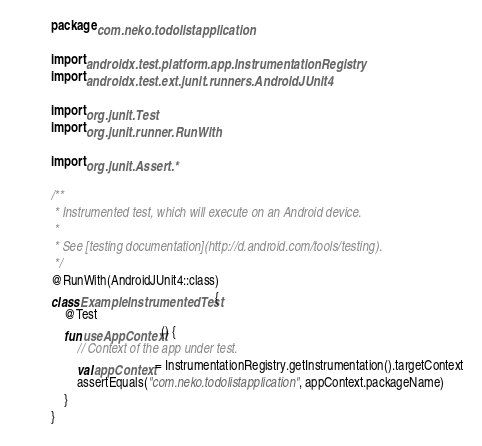Convert code to text. <code><loc_0><loc_0><loc_500><loc_500><_Kotlin_>package com.neko.todolistapplication

import androidx.test.platform.app.InstrumentationRegistry
import androidx.test.ext.junit.runners.AndroidJUnit4

import org.junit.Test
import org.junit.runner.RunWith

import org.junit.Assert.*

/**
 * Instrumented test, which will execute on an Android device.
 *
 * See [testing documentation](http://d.android.com/tools/testing).
 */
@RunWith(AndroidJUnit4::class)
class ExampleInstrumentedTest {
    @Test
    fun useAppContext() {
        // Context of the app under test.
        val appContext = InstrumentationRegistry.getInstrumentation().targetContext
        assertEquals("com.neko.todolistapplication", appContext.packageName)
    }
}</code> 